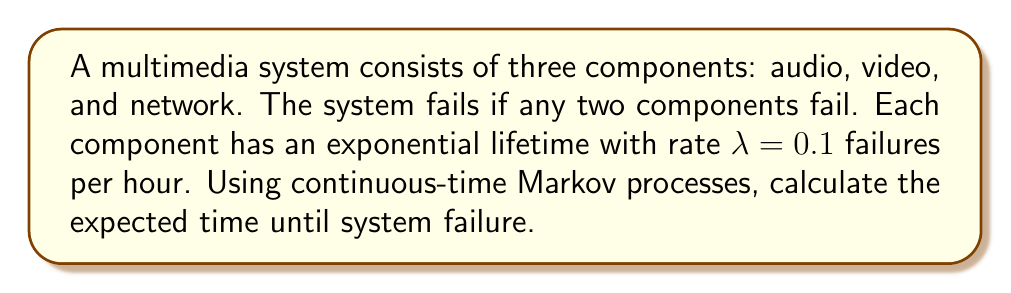Give your solution to this math problem. To solve this problem, we'll use a continuous-time Markov process model:

1) First, define the states:
   State 0: All components working
   State 1: One component has failed
   State 2: Two or more components have failed (system failure)

2) Set up the transition rate matrix Q:
   $$Q = \begin{bmatrix}
   -3\lambda & 3\lambda & 0 \\
   0 & -2\lambda & 2\lambda \\
   0 & 0 & 0
   \end{bmatrix}$$

3) The expected time to absorption (system failure) is given by:
   $$\mathbb{E}[T] = -\mathbf{e}_1^T (Q_{11})^{-1} \mathbf{1}$$
   where $Q_{11}$ is the submatrix of Q excluding the absorbing state.

4) Calculate $Q_{11}$:
   $$Q_{11} = \begin{bmatrix}
   -3\lambda & 3\lambda \\
   0 & -2\lambda
   \end{bmatrix}$$

5) Find $(Q_{11})^{-1}$:
   $$(Q_{11})^{-1} = \begin{bmatrix}
   -\frac{1}{3\lambda} & -\frac{1}{2\lambda} \\
   0 & -\frac{1}{2\lambda}
   \end{bmatrix}$$

6) Calculate $\mathbb{E}[T]$:
   $$\mathbb{E}[T] = -[1 \quad 0] \begin{bmatrix}
   -\frac{1}{3\lambda} & -\frac{1}{2\lambda} \\
   0 & -\frac{1}{2\lambda}
   \end{bmatrix} \begin{bmatrix}
   1 \\
   1
   \end{bmatrix}$$

   $$\mathbb{E}[T] = \frac{1}{3\lambda} + \frac{1}{2\lambda} = \frac{5}{6\lambda}$$

7) Substitute $\lambda = 0.1$:
   $$\mathbb{E}[T] = \frac{5}{6 \cdot 0.1} = \frac{50}{6} = 8.33 \text{ hours}$$
Answer: 8.33 hours 